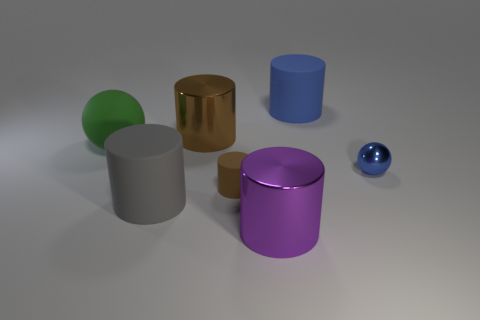Are there any yellow balls made of the same material as the tiny blue ball?
Make the answer very short. No. There is a thing that is to the right of the large purple thing and in front of the big blue cylinder; what is its color?
Your answer should be very brief. Blue. How many other objects are the same color as the large sphere?
Keep it short and to the point. 0. There is a sphere on the left side of the big matte cylinder that is behind the sphere to the left of the large blue cylinder; what is its material?
Ensure brevity in your answer.  Rubber. How many cylinders are either small gray matte objects or blue rubber things?
Offer a terse response. 1. Is there any other thing that is the same size as the brown rubber cylinder?
Your answer should be compact. Yes. How many blue objects are in front of the metallic cylinder that is on the left side of the large shiny cylinder that is in front of the small ball?
Your response must be concise. 1. Does the tiny matte object have the same shape as the large purple metal thing?
Your response must be concise. Yes. Does the blue object in front of the large blue rubber cylinder have the same material as the ball that is left of the gray rubber cylinder?
Provide a short and direct response. No. What number of things are either big metallic things behind the gray rubber thing or metallic cylinders that are behind the tiny ball?
Offer a very short reply. 1. 